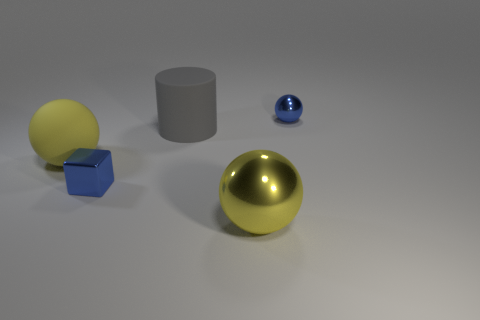Add 5 spheres. How many objects exist? 10 Subtract all metal spheres. How many spheres are left? 1 Add 5 gray matte objects. How many gray matte objects exist? 6 Subtract all blue spheres. How many spheres are left? 2 Subtract 1 blue blocks. How many objects are left? 4 Subtract all cubes. How many objects are left? 4 Subtract 1 blocks. How many blocks are left? 0 Subtract all yellow cylinders. Subtract all cyan balls. How many cylinders are left? 1 Subtract all brown cylinders. How many purple balls are left? 0 Subtract all gray shiny cubes. Subtract all small cubes. How many objects are left? 4 